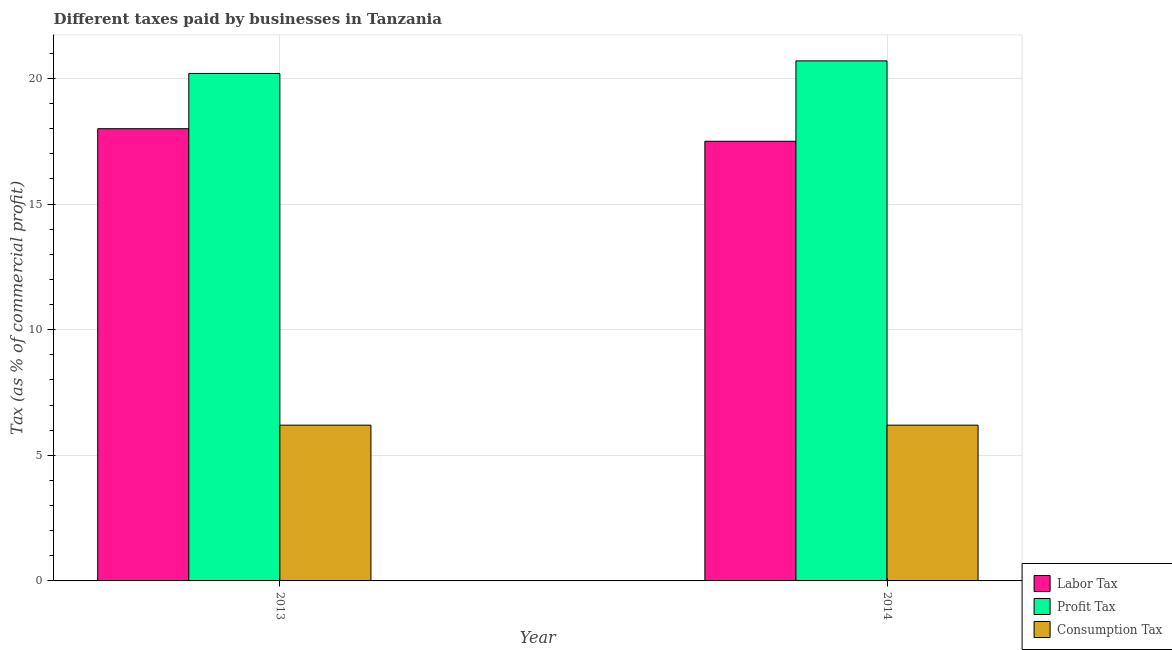How many different coloured bars are there?
Ensure brevity in your answer.  3. Are the number of bars per tick equal to the number of legend labels?
Offer a very short reply. Yes. How many bars are there on the 1st tick from the left?
Your answer should be very brief. 3. How many bars are there on the 1st tick from the right?
Your answer should be compact. 3. In how many cases, is the number of bars for a given year not equal to the number of legend labels?
Make the answer very short. 0. What is the percentage of profit tax in 2014?
Ensure brevity in your answer.  20.7. Across all years, what is the maximum percentage of labor tax?
Make the answer very short. 18. Across all years, what is the minimum percentage of consumption tax?
Your response must be concise. 6.2. In which year was the percentage of profit tax maximum?
Provide a succinct answer. 2014. What is the total percentage of profit tax in the graph?
Your response must be concise. 40.9. What is the difference between the percentage of consumption tax in 2014 and the percentage of labor tax in 2013?
Provide a short and direct response. 0. What is the average percentage of consumption tax per year?
Provide a short and direct response. 6.2. In the year 2014, what is the difference between the percentage of profit tax and percentage of consumption tax?
Provide a short and direct response. 0. What does the 1st bar from the left in 2014 represents?
Your answer should be compact. Labor Tax. What does the 3rd bar from the right in 2013 represents?
Give a very brief answer. Labor Tax. How many bars are there?
Make the answer very short. 6. What is the difference between two consecutive major ticks on the Y-axis?
Ensure brevity in your answer.  5. Are the values on the major ticks of Y-axis written in scientific E-notation?
Provide a succinct answer. No. Does the graph contain grids?
Your answer should be very brief. Yes. How many legend labels are there?
Offer a very short reply. 3. How are the legend labels stacked?
Ensure brevity in your answer.  Vertical. What is the title of the graph?
Your answer should be compact. Different taxes paid by businesses in Tanzania. What is the label or title of the X-axis?
Ensure brevity in your answer.  Year. What is the label or title of the Y-axis?
Your answer should be very brief. Tax (as % of commercial profit). What is the Tax (as % of commercial profit) in Labor Tax in 2013?
Your response must be concise. 18. What is the Tax (as % of commercial profit) of Profit Tax in 2013?
Make the answer very short. 20.2. What is the Tax (as % of commercial profit) in Profit Tax in 2014?
Offer a very short reply. 20.7. What is the Tax (as % of commercial profit) of Consumption Tax in 2014?
Your response must be concise. 6.2. Across all years, what is the maximum Tax (as % of commercial profit) in Profit Tax?
Offer a terse response. 20.7. Across all years, what is the maximum Tax (as % of commercial profit) of Consumption Tax?
Your response must be concise. 6.2. Across all years, what is the minimum Tax (as % of commercial profit) of Profit Tax?
Offer a terse response. 20.2. Across all years, what is the minimum Tax (as % of commercial profit) of Consumption Tax?
Offer a terse response. 6.2. What is the total Tax (as % of commercial profit) of Labor Tax in the graph?
Ensure brevity in your answer.  35.5. What is the total Tax (as % of commercial profit) of Profit Tax in the graph?
Your answer should be very brief. 40.9. What is the total Tax (as % of commercial profit) of Consumption Tax in the graph?
Your answer should be very brief. 12.4. What is the difference between the Tax (as % of commercial profit) in Labor Tax in 2013 and that in 2014?
Your answer should be compact. 0.5. What is the difference between the Tax (as % of commercial profit) of Profit Tax in 2013 and that in 2014?
Keep it short and to the point. -0.5. What is the difference between the Tax (as % of commercial profit) of Consumption Tax in 2013 and that in 2014?
Your response must be concise. 0. What is the difference between the Tax (as % of commercial profit) of Labor Tax in 2013 and the Tax (as % of commercial profit) of Profit Tax in 2014?
Keep it short and to the point. -2.7. What is the difference between the Tax (as % of commercial profit) of Labor Tax in 2013 and the Tax (as % of commercial profit) of Consumption Tax in 2014?
Your response must be concise. 11.8. What is the average Tax (as % of commercial profit) in Labor Tax per year?
Provide a succinct answer. 17.75. What is the average Tax (as % of commercial profit) in Profit Tax per year?
Provide a succinct answer. 20.45. In the year 2014, what is the difference between the Tax (as % of commercial profit) in Profit Tax and Tax (as % of commercial profit) in Consumption Tax?
Offer a terse response. 14.5. What is the ratio of the Tax (as % of commercial profit) in Labor Tax in 2013 to that in 2014?
Make the answer very short. 1.03. What is the ratio of the Tax (as % of commercial profit) of Profit Tax in 2013 to that in 2014?
Provide a succinct answer. 0.98. What is the difference between the highest and the second highest Tax (as % of commercial profit) of Consumption Tax?
Your answer should be very brief. 0. What is the difference between the highest and the lowest Tax (as % of commercial profit) in Labor Tax?
Give a very brief answer. 0.5. 